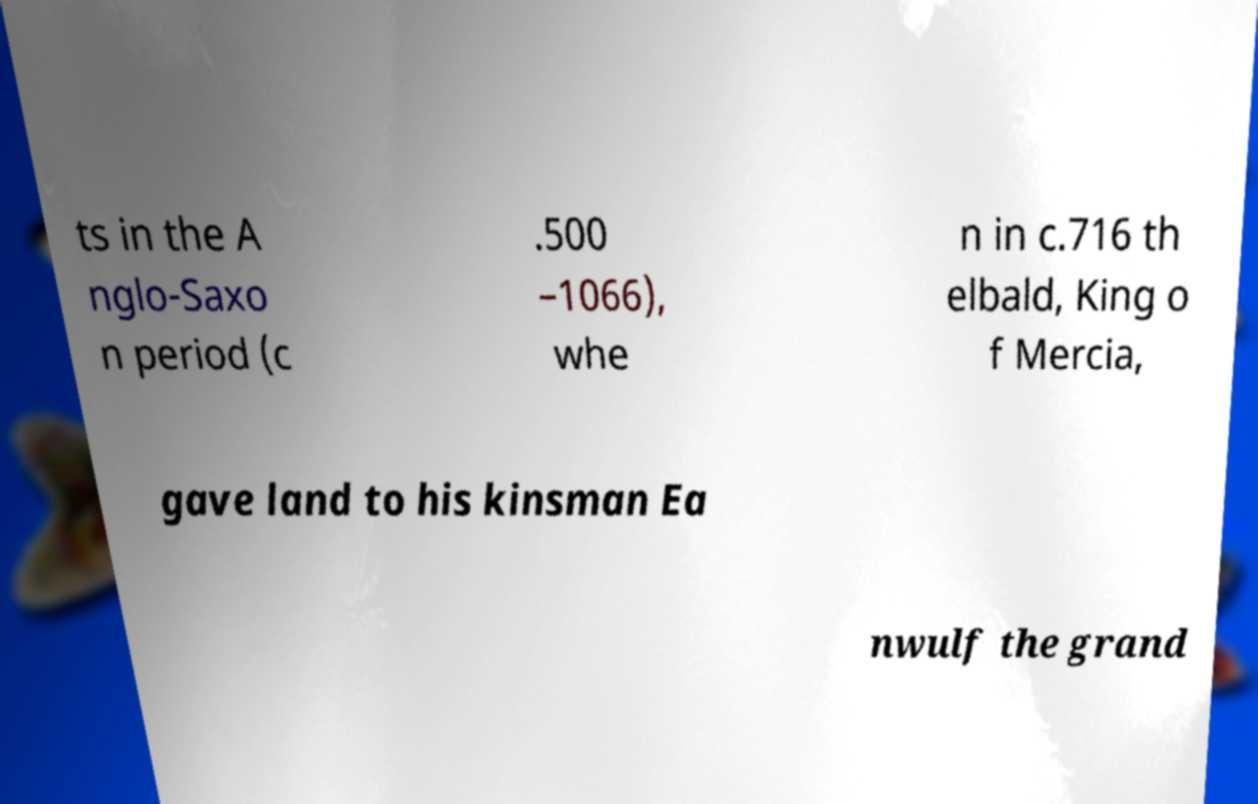Please identify and transcribe the text found in this image. ts in the A nglo-Saxo n period (c .500 –1066), whe n in c.716 th elbald, King o f Mercia, gave land to his kinsman Ea nwulf the grand 